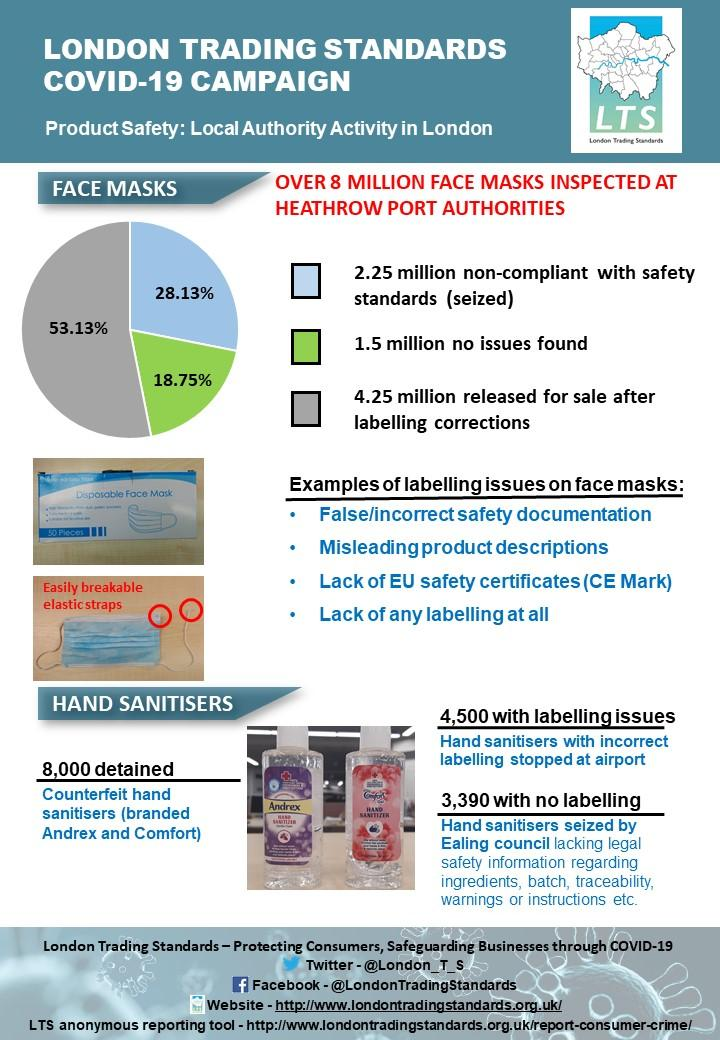List a handful of essential elements in this visual. After corrections, a total of 53.13% of face masks were released for sale. Andrex and Comfort were the brand names used on fake sanitisers that were found to be contaminated with bacteria. Ealing Council seized hand sanitizers that lacked warnings or instructions. The misleading product descriptions are stated as the second example of the face mask labeling issue. The investigation found that out of the 3,390 hand sanitizers tested, 3,390 did not have safety information, warnings, or instructions. 